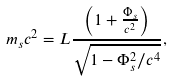<formula> <loc_0><loc_0><loc_500><loc_500>m _ { s } c ^ { 2 } = L \frac { \left ( 1 + \frac { \Phi _ { s } } { c ^ { 2 } } \right ) } { \sqrt { 1 - \Phi _ { s } ^ { 2 } / c ^ { 4 } } } ,</formula> 